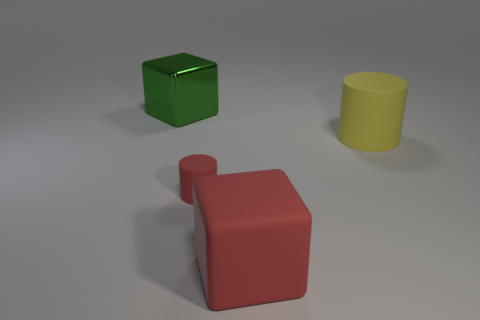Is there anything else that is made of the same material as the green cube?
Provide a succinct answer. No. What number of cylinders are behind the cylinder to the left of the cylinder right of the small red rubber thing?
Provide a succinct answer. 1. Are there more big red objects than large shiny cylinders?
Offer a terse response. Yes. What number of small red cylinders are there?
Provide a short and direct response. 1. What is the shape of the object left of the red matte thing behind the large cube right of the big shiny thing?
Make the answer very short. Cube. Is the number of big green metal objects that are right of the tiny thing less than the number of small red cylinders that are on the left side of the red rubber cube?
Provide a short and direct response. Yes. There is a large rubber object left of the large yellow matte cylinder; is its shape the same as the object that is to the left of the tiny red matte thing?
Offer a terse response. Yes. What is the shape of the red rubber thing behind the big block that is on the right side of the big green metal object?
Provide a short and direct response. Cylinder. There is a cube that is the same color as the tiny rubber cylinder; what size is it?
Offer a very short reply. Large. Are there any large things that have the same material as the yellow cylinder?
Make the answer very short. Yes. 